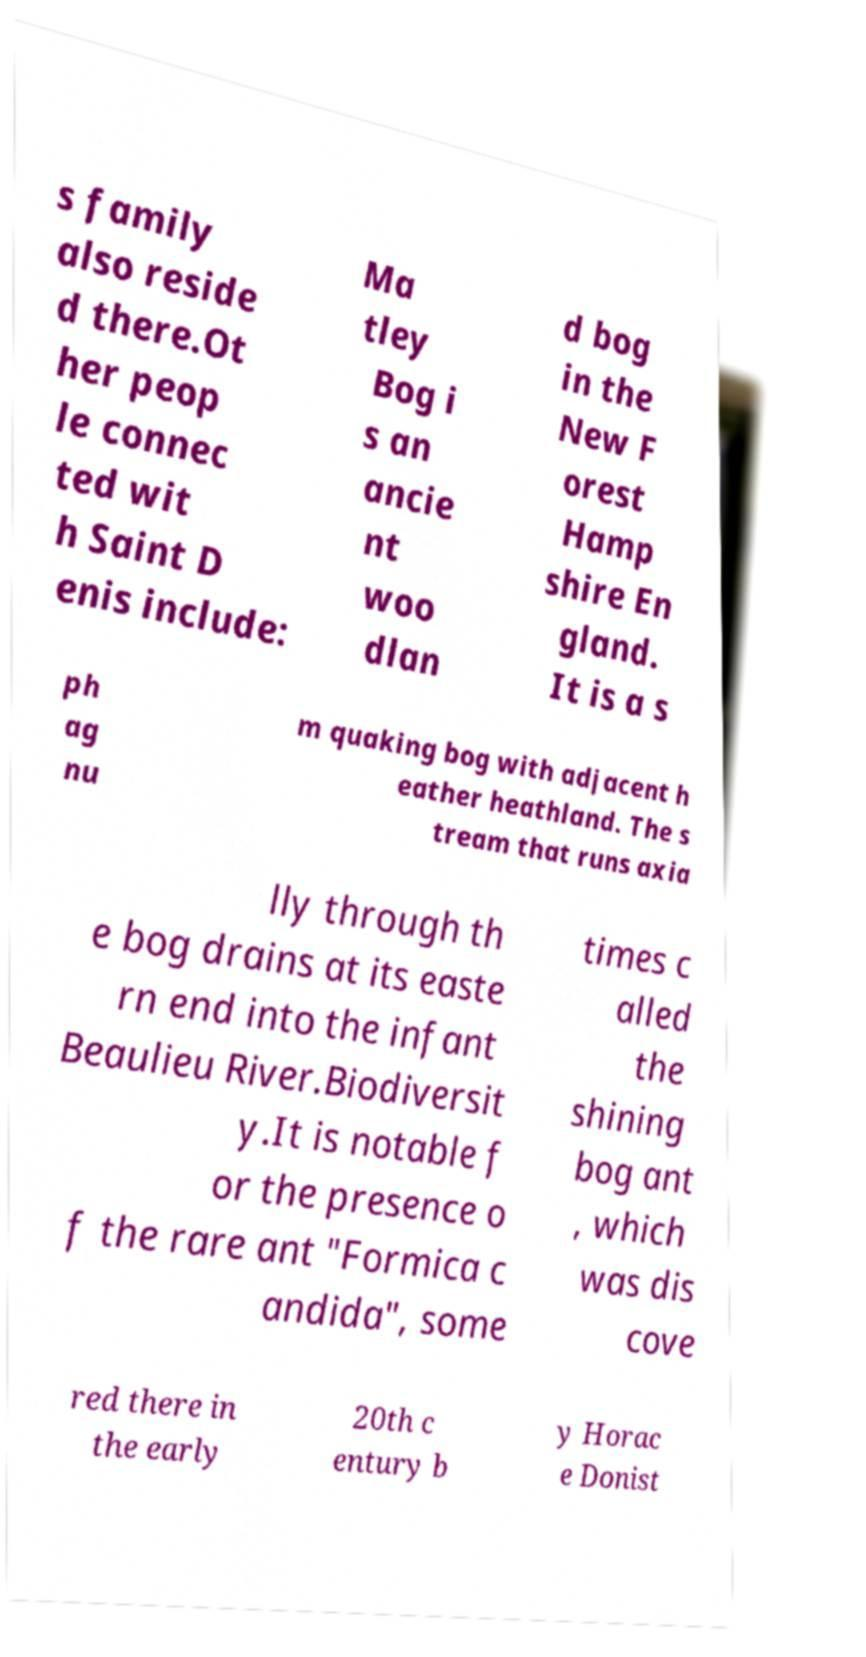Can you accurately transcribe the text from the provided image for me? s family also reside d there.Ot her peop le connec ted wit h Saint D enis include: Ma tley Bog i s an ancie nt woo dlan d bog in the New F orest Hamp shire En gland. It is a s ph ag nu m quaking bog with adjacent h eather heathland. The s tream that runs axia lly through th e bog drains at its easte rn end into the infant Beaulieu River.Biodiversit y.It is notable f or the presence o f the rare ant "Formica c andida", some times c alled the shining bog ant , which was dis cove red there in the early 20th c entury b y Horac e Donist 